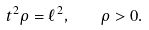<formula> <loc_0><loc_0><loc_500><loc_500>t ^ { 2 } \rho = \ell ^ { 2 } , \quad \rho > 0 .</formula> 